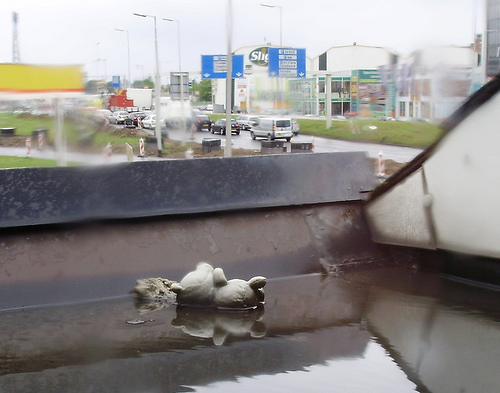<image>
Is the bear under the car? No. The bear is not positioned under the car. The vertical relationship between these objects is different. 